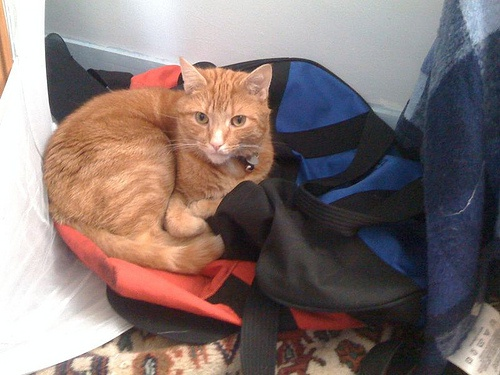Describe the objects in this image and their specific colors. I can see backpack in tan, black, navy, and darkblue tones and cat in tan and salmon tones in this image. 